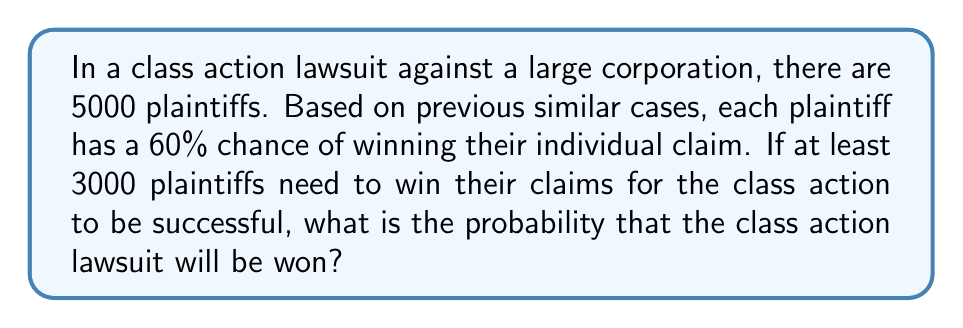Help me with this question. To solve this problem, we need to use the binomial probability distribution. Here's a step-by-step explanation:

1. Identify the parameters:
   - $n$ = number of trials (plaintiffs) = 5000
   - $p$ = probability of success for each trial = 0.60
   - $X$ = number of successes (winning claims)
   - We need to find $P(X \geq 3000)$

2. The probability of exactly $k$ successes in $n$ trials is given by the binomial probability formula:

   $$P(X = k) = \binom{n}{k} p^k (1-p)^{n-k}$$

3. However, calculating this for each $k$ from 3000 to 5000 would be time-consuming. Instead, we can use the normal approximation to the binomial distribution since $n$ is large and $np(1-p) > 5$.

4. Calculate the mean ($\mu$) and standard deviation ($\sigma$) of the normal approximation:
   
   $$\mu = np = 5000 \cdot 0.60 = 3000$$
   $$\sigma = \sqrt{np(1-p)} = \sqrt{5000 \cdot 0.60 \cdot 0.40} = \sqrt{1200} \approx 34.64$$

5. Calculate the z-score for 3000 (with continuity correction):
   
   $$z = \frac{2999.5 - 3000}{34.64} \approx -0.0144$$

6. Find the probability using the standard normal distribution:
   
   $$P(X \geq 3000) = P(Z \geq -0.0144) = 1 - P(Z < -0.0144) \approx 1 - 0.4943 = 0.5057$$

Therefore, the probability of winning the class action lawsuit is approximately 0.5057 or 50.57%.
Answer: The probability of winning the class action lawsuit is approximately 0.5057 or 50.57%. 